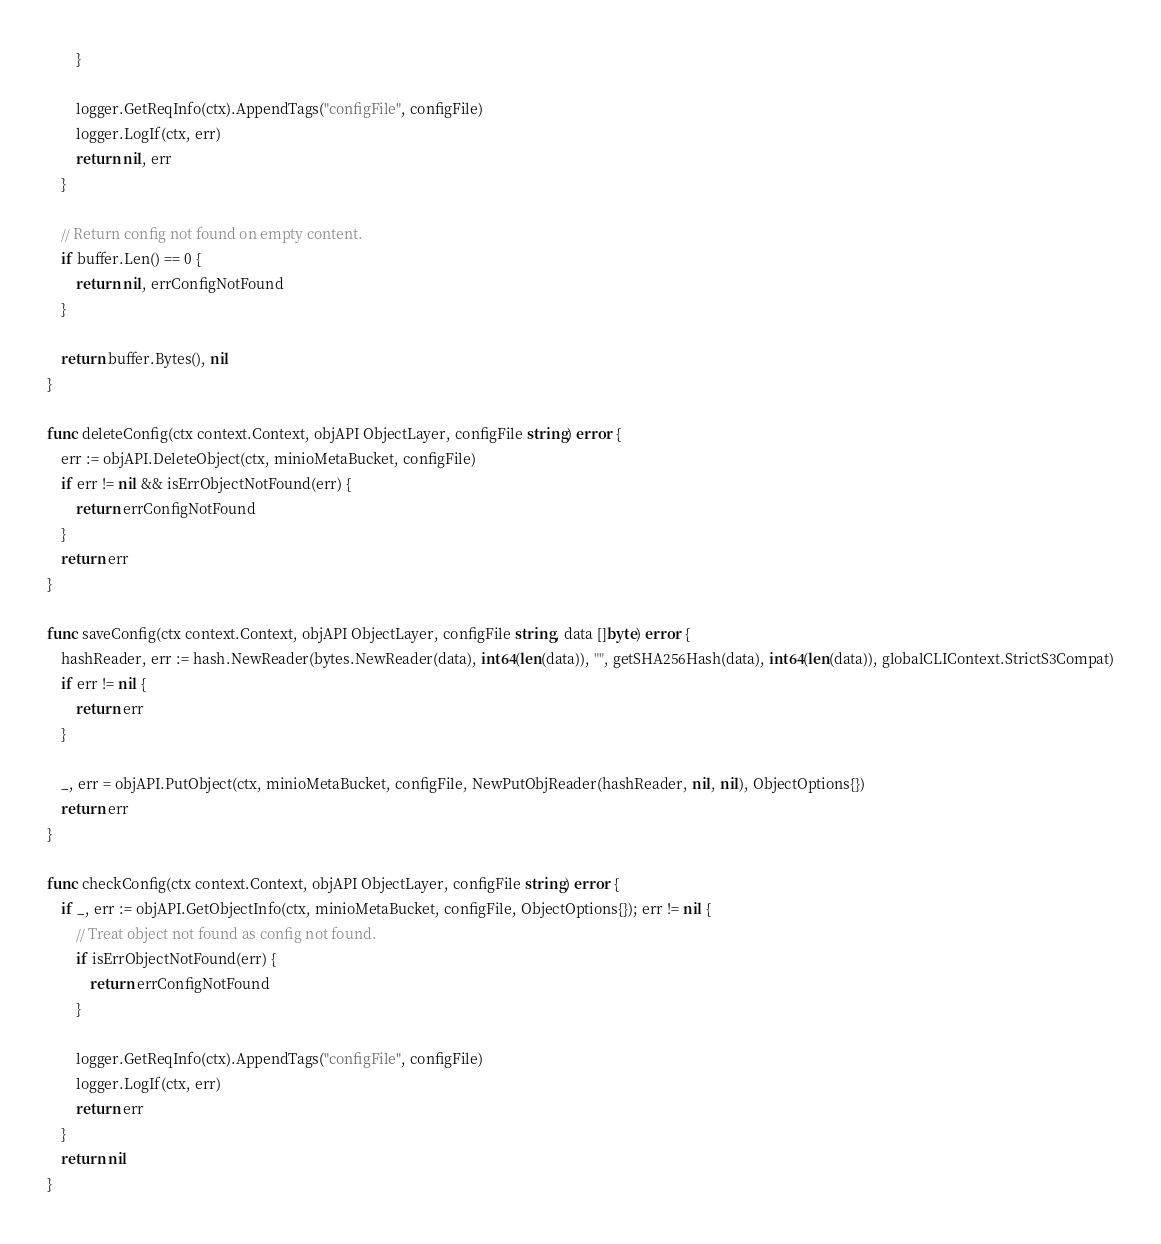Convert code to text. <code><loc_0><loc_0><loc_500><loc_500><_Go_>		}

		logger.GetReqInfo(ctx).AppendTags("configFile", configFile)
		logger.LogIf(ctx, err)
		return nil, err
	}

	// Return config not found on empty content.
	if buffer.Len() == 0 {
		return nil, errConfigNotFound
	}

	return buffer.Bytes(), nil
}

func deleteConfig(ctx context.Context, objAPI ObjectLayer, configFile string) error {
	err := objAPI.DeleteObject(ctx, minioMetaBucket, configFile)
	if err != nil && isErrObjectNotFound(err) {
		return errConfigNotFound
	}
	return err
}

func saveConfig(ctx context.Context, objAPI ObjectLayer, configFile string, data []byte) error {
	hashReader, err := hash.NewReader(bytes.NewReader(data), int64(len(data)), "", getSHA256Hash(data), int64(len(data)), globalCLIContext.StrictS3Compat)
	if err != nil {
		return err
	}

	_, err = objAPI.PutObject(ctx, minioMetaBucket, configFile, NewPutObjReader(hashReader, nil, nil), ObjectOptions{})
	return err
}

func checkConfig(ctx context.Context, objAPI ObjectLayer, configFile string) error {
	if _, err := objAPI.GetObjectInfo(ctx, minioMetaBucket, configFile, ObjectOptions{}); err != nil {
		// Treat object not found as config not found.
		if isErrObjectNotFound(err) {
			return errConfigNotFound
		}

		logger.GetReqInfo(ctx).AppendTags("configFile", configFile)
		logger.LogIf(ctx, err)
		return err
	}
	return nil
}
</code> 